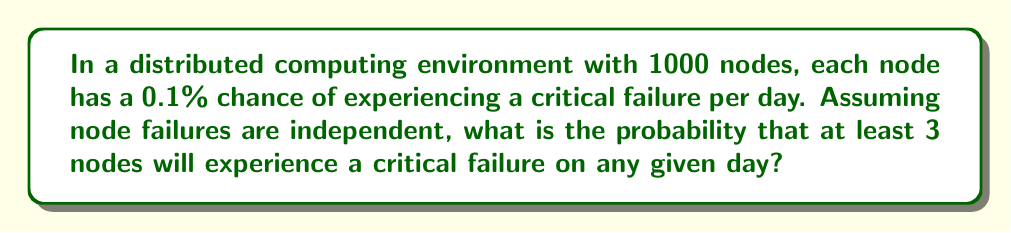Can you solve this math problem? Let's approach this step-by-step:

1) First, we need to recognize this as a binomial probability problem. We have a fixed number of trials (1000 nodes), each with the same probability of success (0.1% chance of failure).

2) Let X be the random variable representing the number of nodes that fail. We want to find P(X ≥ 3).

3) It's often easier to calculate the complement of this probability: P(X ≥ 3) = 1 - P(X < 3) = 1 - P(X ≤ 2)

4) The probability of exactly k successes in n trials is given by the binomial probability formula:

   $$P(X = k) = \binom{n}{k} p^k (1-p)^{n-k}$$

   where n = 1000, p = 0.001

5) We need to calculate P(X = 0) + P(X = 1) + P(X = 2):

   $$P(X \leq 2) = \binom{1000}{0} (0.001)^0 (0.999)^{1000} + \binom{1000}{1} (0.001)^1 (0.999)^{999} + \binom{1000}{2} (0.001)^2 (0.999)^{998}$$

6) Let's calculate each term:

   $$P(X = 0) = 1 \cdot 1 \cdot 0.368 = 0.368$$
   $$P(X = 1) = 1000 \cdot 0.001 \cdot 0.368 = 0.368$$
   $$P(X = 2) = 499500 \cdot 0.000001 \cdot 0.368 = 0.184$$

7) Sum these probabilities:

   $$P(X \leq 2) = 0.368 + 0.368 + 0.184 = 0.920$$

8) Therefore, the probability of at least 3 failures is:

   $$P(X \geq 3) = 1 - P(X \leq 2) = 1 - 0.920 = 0.080$$
Answer: 0.080 